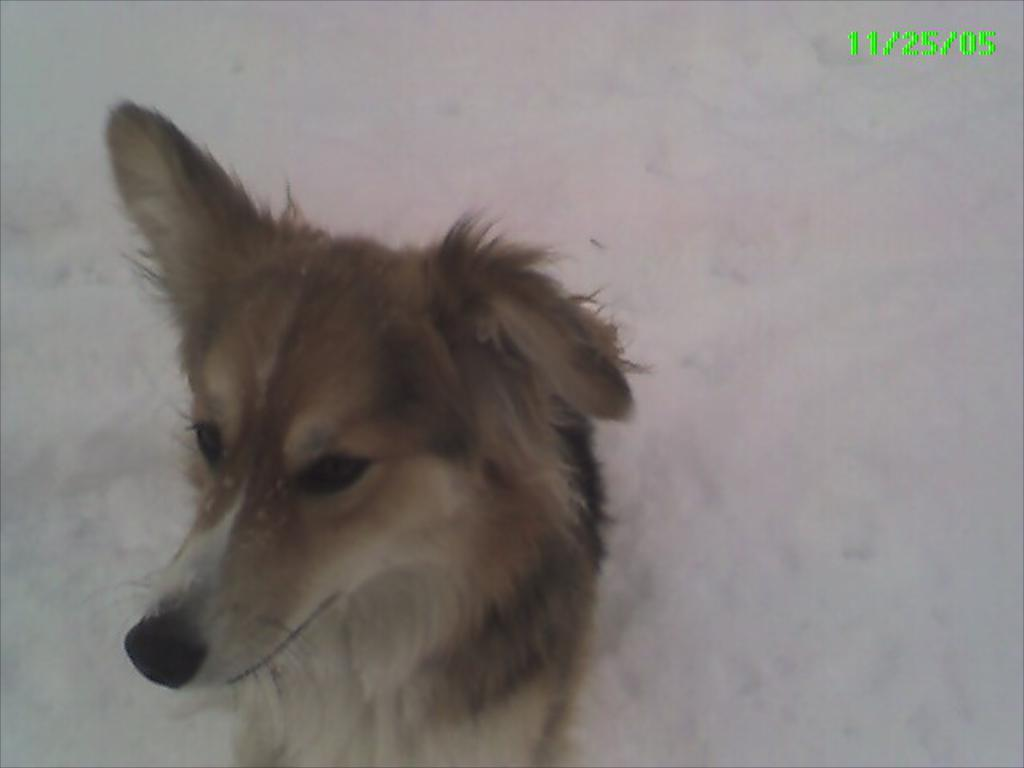What animal is present in the image? There is a dog in the image. Where is the dog located in the image? The dog is at the bottom of the image. What type of weather is depicted in the image? There is snow visible in the image, indicating a cold or wintery setting. What color and location are the numbers in the image? The numbers are in green color and located in the top right-hand side of the image. What type of cake is being served to the pest in the image? There is no cake or pest present in the image; it features a dog in a snowy setting with numbers in the top right-hand side. 